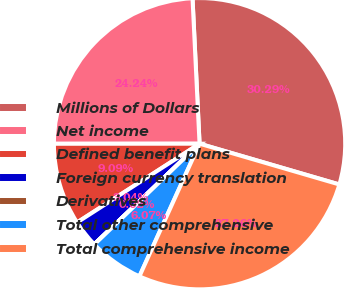Convert chart. <chart><loc_0><loc_0><loc_500><loc_500><pie_chart><fcel>Millions of Dollars<fcel>Net income<fcel>Defined benefit plans<fcel>Foreign currency translation<fcel>Derivatives<fcel>Total other comprehensive<fcel>Total comprehensive income<nl><fcel>30.29%<fcel>24.24%<fcel>9.09%<fcel>3.04%<fcel>0.02%<fcel>6.07%<fcel>27.26%<nl></chart> 